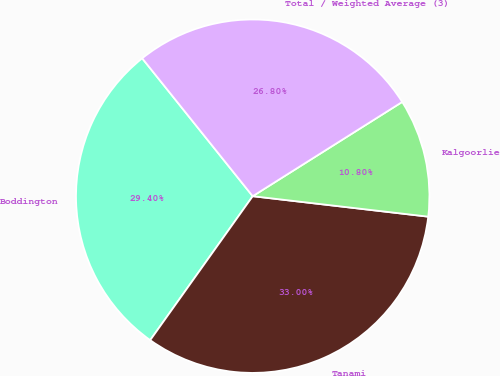Convert chart to OTSL. <chart><loc_0><loc_0><loc_500><loc_500><pie_chart><fcel>Boddington<fcel>Tanami<fcel>Kalgoorlie<fcel>Total / Weighted Average (3)<nl><fcel>29.4%<fcel>33.0%<fcel>10.8%<fcel>26.8%<nl></chart> 